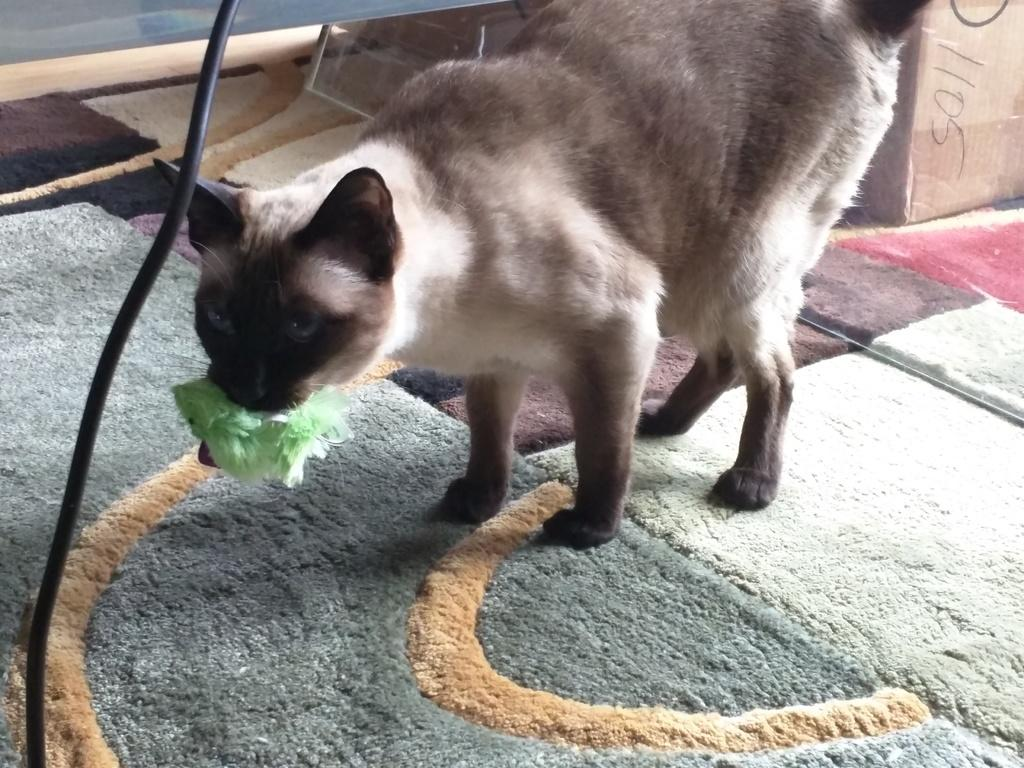What type of animal is on the carpet in the image? There is a cat on the carpet in the image. What is the cat doing in the image? The cat is holding something in its mouth. What else can be seen in the image besides the cat? There is a wire and a box in the image. Where is the box located in the image? The box is in the right top corner of the image. What type of brass bead is the cat using to conduct business in the image? There is no brass bead or business activity depicted in the image; it features a cat holding something in its mouth and other objects like a wire and a box. 